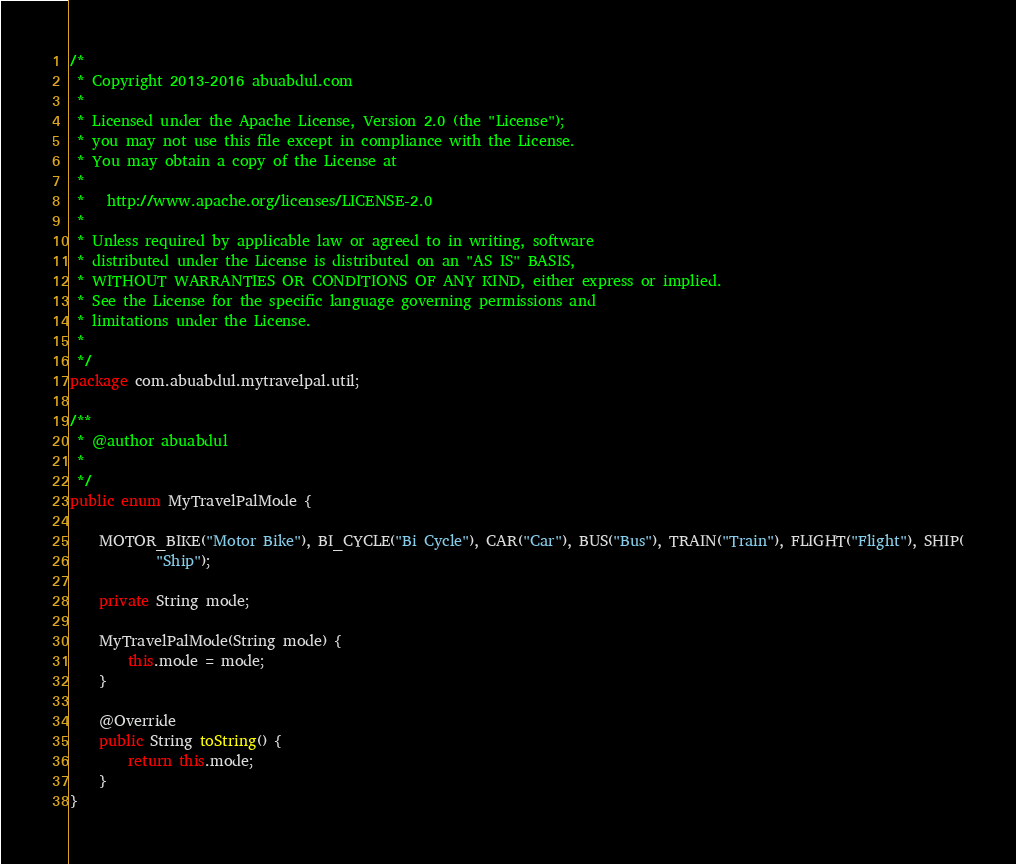<code> <loc_0><loc_0><loc_500><loc_500><_Java_>/*
 * Copyright 2013-2016 abuabdul.com
 *
 * Licensed under the Apache License, Version 2.0 (the "License");
 * you may not use this file except in compliance with the License.
 * You may obtain a copy of the License at
 *
 *   http://www.apache.org/licenses/LICENSE-2.0
 *
 * Unless required by applicable law or agreed to in writing, software
 * distributed under the License is distributed on an "AS IS" BASIS,
 * WITHOUT WARRANTIES OR CONDITIONS OF ANY KIND, either express or implied.
 * See the License for the specific language governing permissions and
 * limitations under the License.
 * 
 */
package com.abuabdul.mytravelpal.util;

/**
 * @author abuabdul
 *
 */
public enum MyTravelPalMode {

	MOTOR_BIKE("Motor Bike"), BI_CYCLE("Bi Cycle"), CAR("Car"), BUS("Bus"), TRAIN("Train"), FLIGHT("Flight"), SHIP(
			"Ship");

	private String mode;

	MyTravelPalMode(String mode) {
		this.mode = mode;
	}

	@Override
	public String toString() {
		return this.mode;
	}
}
</code> 